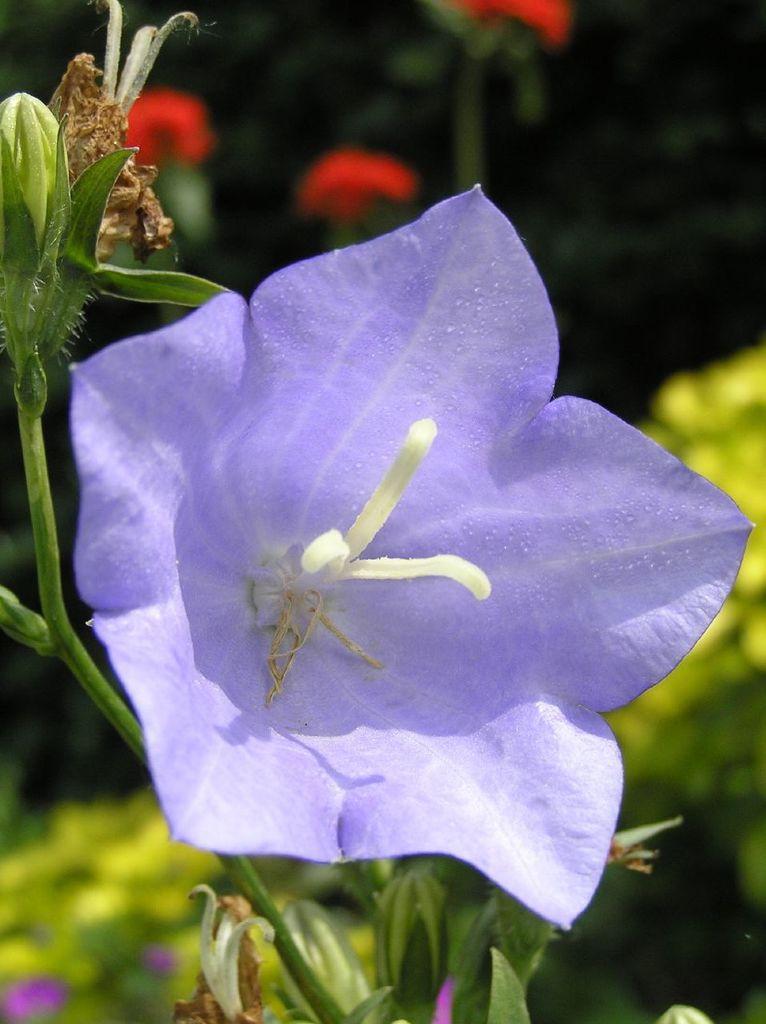In one or two sentences, can you explain what this image depicts? In this image there is a plant, for that plant there is a flower, in the background it is blurred. 